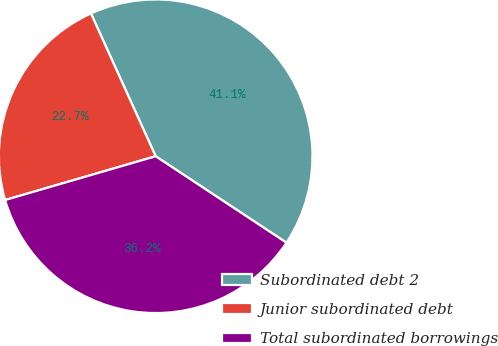<chart> <loc_0><loc_0><loc_500><loc_500><pie_chart><fcel>Subordinated debt 2<fcel>Junior subordinated debt<fcel>Total subordinated borrowings<nl><fcel>41.07%<fcel>22.73%<fcel>36.2%<nl></chart> 